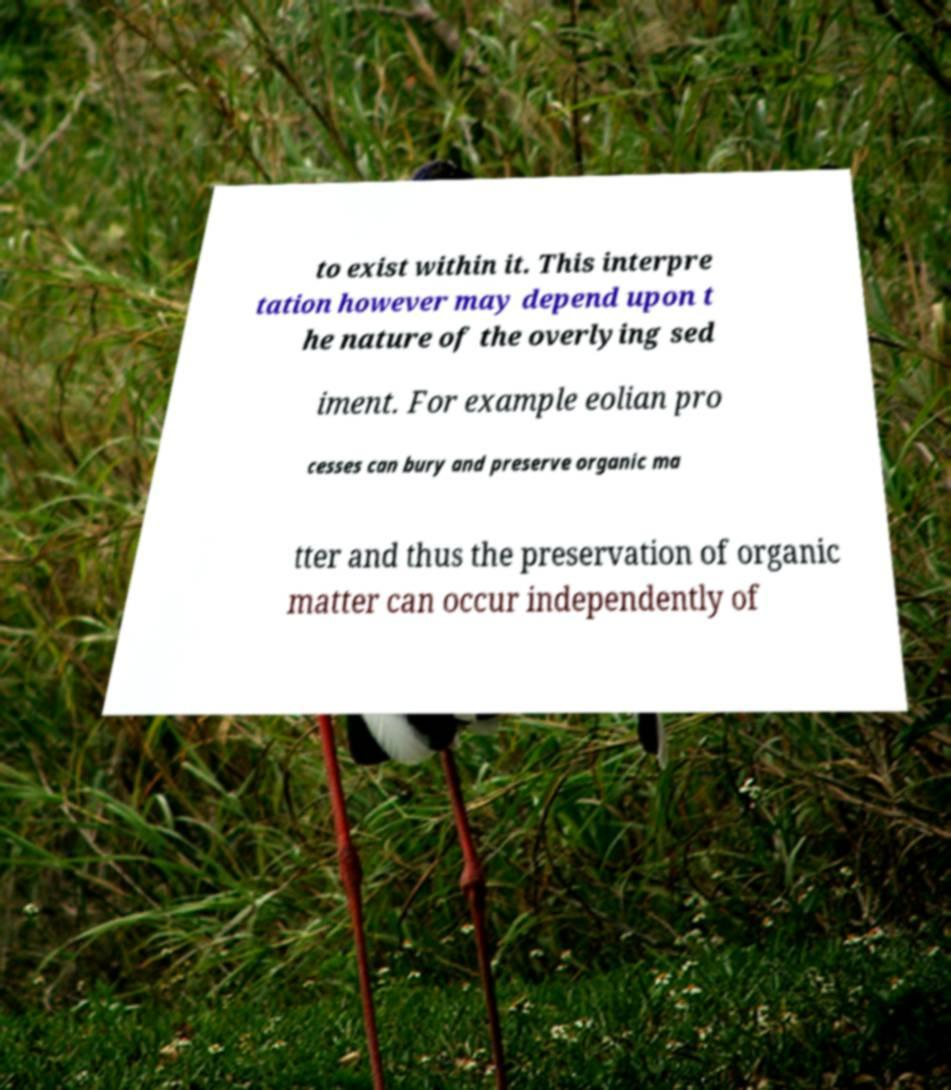I need the written content from this picture converted into text. Can you do that? to exist within it. This interpre tation however may depend upon t he nature of the overlying sed iment. For example eolian pro cesses can bury and preserve organic ma tter and thus the preservation of organic matter can occur independently of 